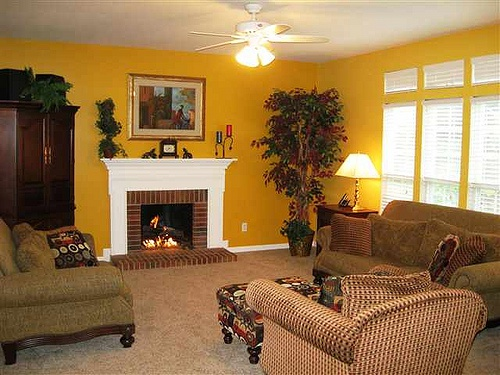Describe the objects in this image and their specific colors. I can see chair in gray, maroon, brown, and tan tones, chair in gray, olive, black, and maroon tones, couch in gray, maroon, black, and brown tones, potted plant in gray, black, olive, and maroon tones, and couch in gray, olive, maroon, and black tones in this image. 